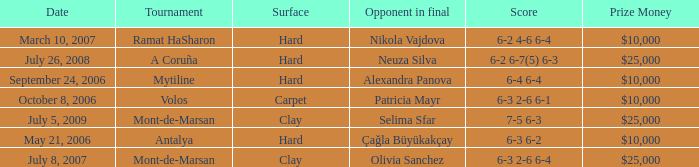What is the surface for the Volos tournament? Carpet. 